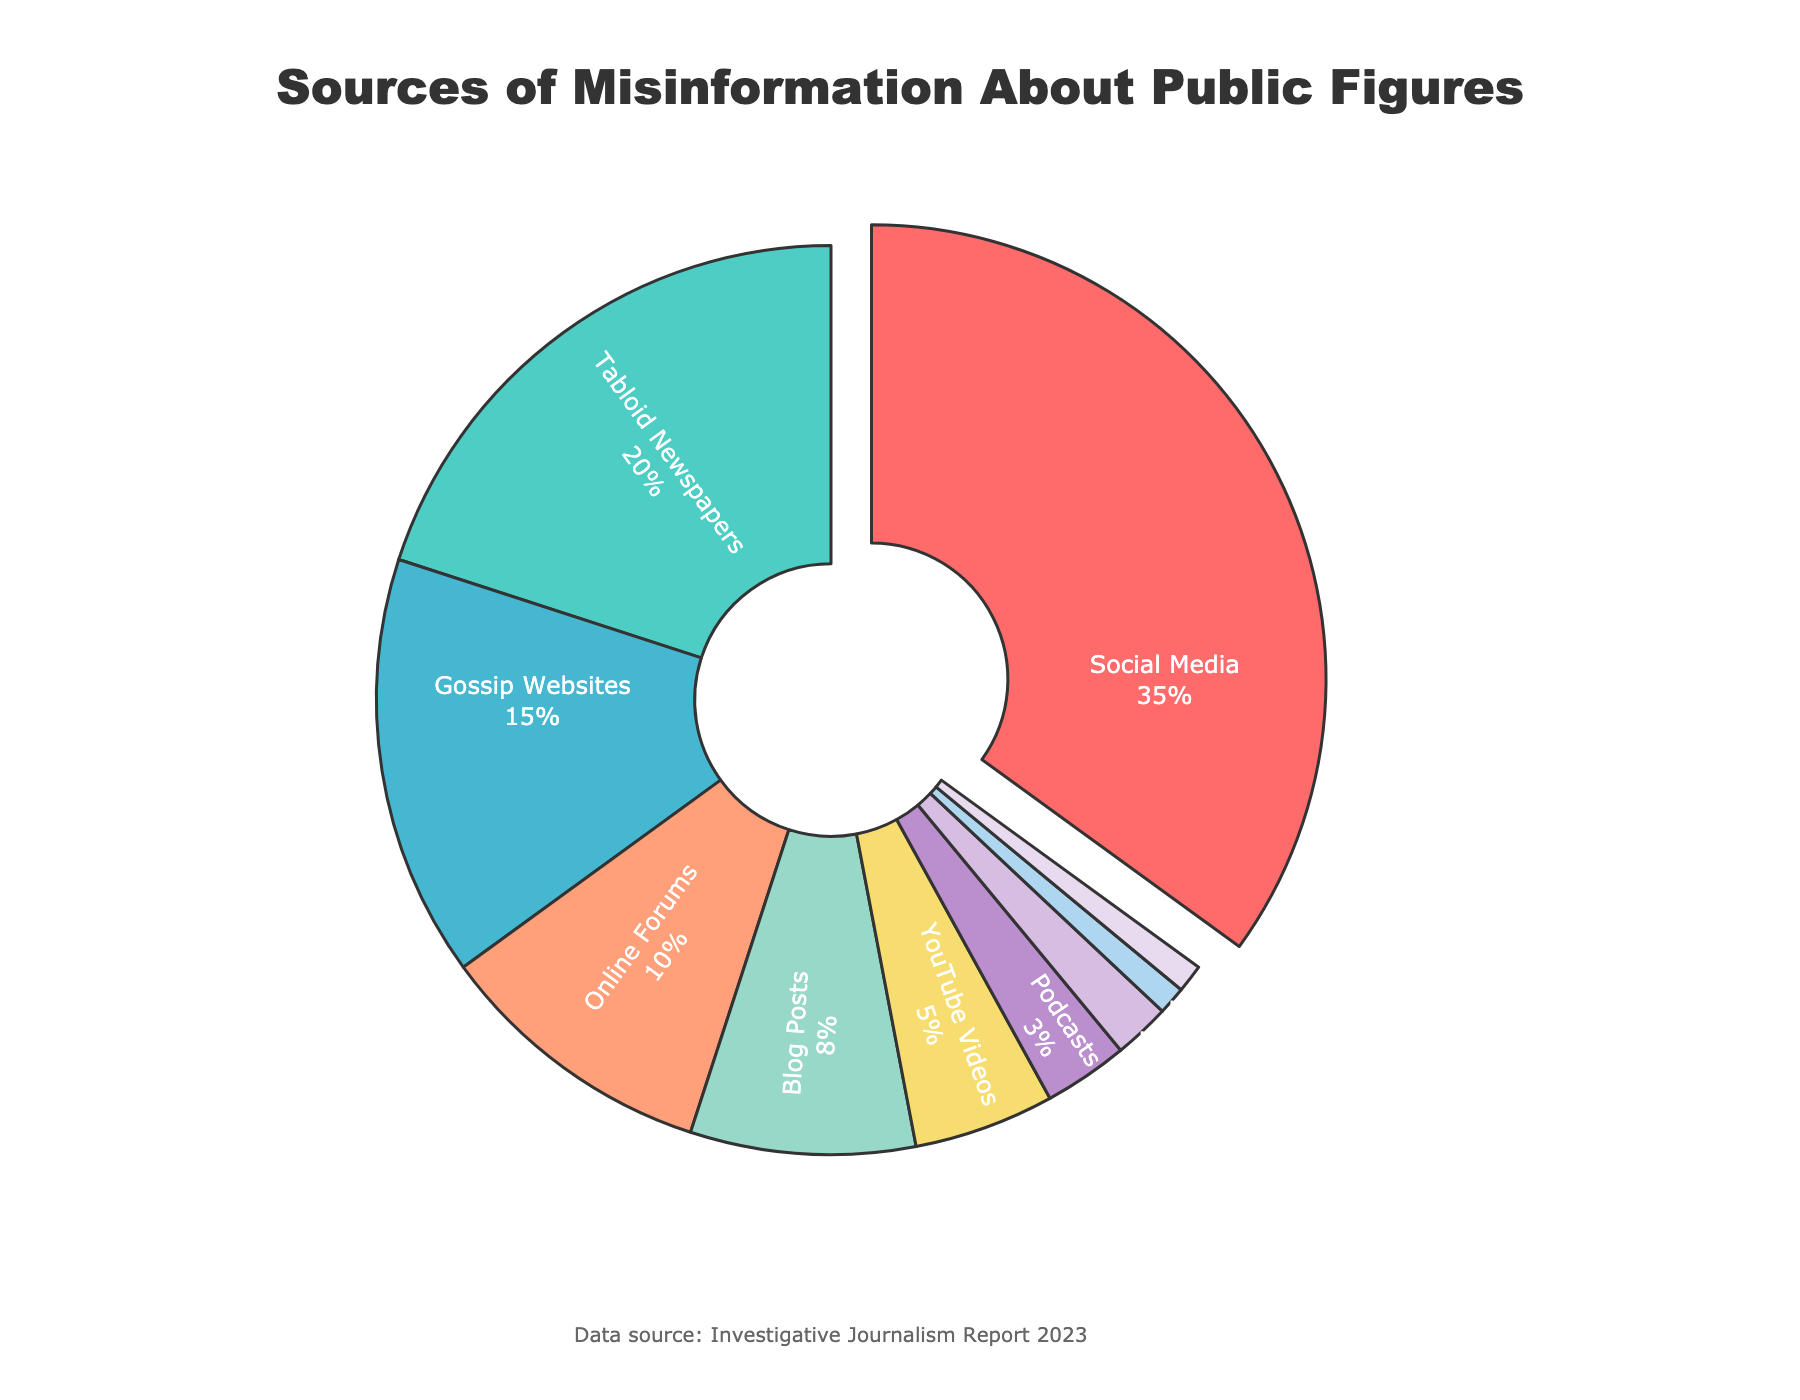What is the most common source of misinformation about public figures? The pie chart shows different media types used for spreading misinformation with their respective percentages. The segment representing 'Social Media' is the largest, indicating it has the highest percentage.
Answer: Social Media How much more percentage does Social Media contribute to misinformation compared to Gossip Websites? The percentage for Social Media is 35%, and for Gossip Websites, it is 15%. The difference is 35% - 15% = 20%.
Answer: 20% Which media type is represented by the color red in the pie chart? The color red is used for Social Media in the pie chart, which is the segment with the highest percentage.
Answer: Social Media Sum the percentages of 'Online Forums', 'YouTube Videos', and 'Podcasts'. According to the pie chart, the percentages are: Online Forums: 10%, YouTube Videos: 5%, Podcasts: 3%. Adding these: 10% + 5% + 3% = 18%.
Answer: 18% What are the least common sources of misinformation, and what is their combined percentage? The pie chart shows that 'Doctored Images' and 'Misleading Memes' have the smallest segments, each contributing 1%. Their combined percentage is 1% + 1% = 2%.
Answer: Doctored Images and Misleading Memes, 2% How does the percentage of misinformation from Tabloid Newspapers compare to that from Blog Posts? The segment for Tabloid Newspapers shows 20%, while Blog Posts show 8%. Tabloid Newspapers contribute a higher percentage.
Answer: Tabloid Newspapers (20%) is higher than Blog Posts (8%) Which media type has the fourth-largest percentage and what is its value? The sorted segments show the fourth-largest belongs to 'Online Forums' with 10%.
Answer: Online Forums, 10% 